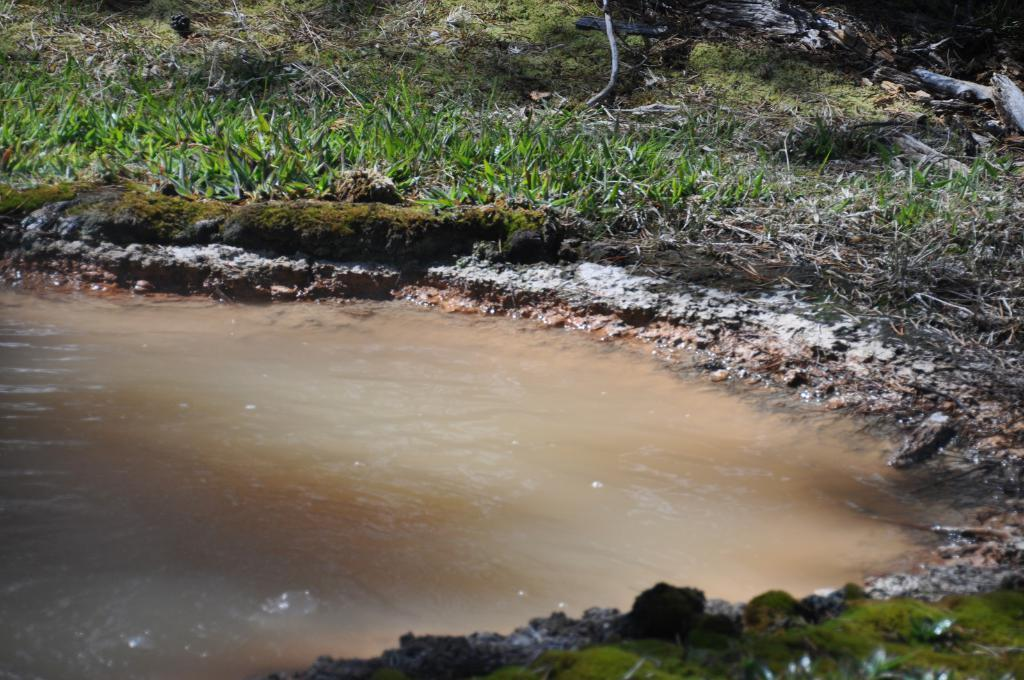What type of natural environment is depicted in the image? The image features water and grass, which suggests a natural setting. Can you describe the water in the image? The water is visible in the image, but no specific details about its appearance or characteristics are provided. What type of vegetation is present in the image? Grass is present in the image. What type of secretary can be seen in the image? There is no secretary present in the image. 